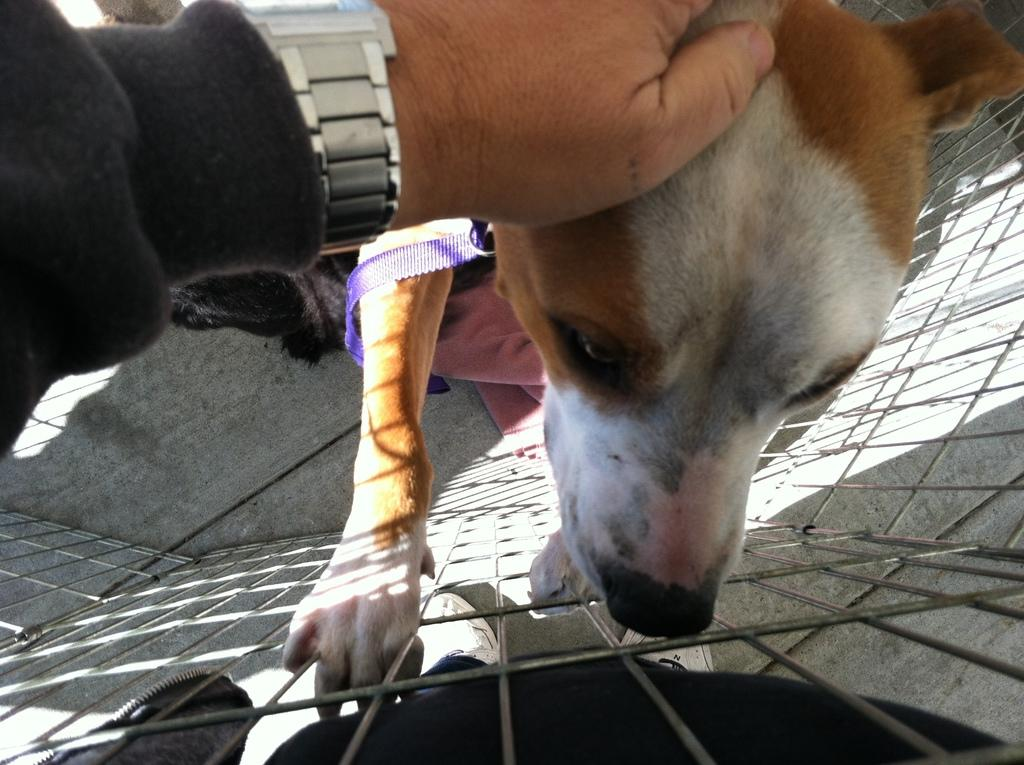What type of clothing item is in the image? There is a white and brown color top in the image. What can be seen on the left side of the image? There is a hand with a wrist watch and a coat on the left side of the image. What is at the bottom of the image? There is an iron grill at the bottom of the image. What type of trucks can be seen driving through the sky in the image? There is no sky or trucks present in the image. 